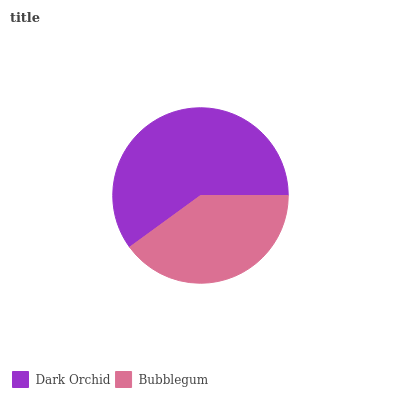Is Bubblegum the minimum?
Answer yes or no. Yes. Is Dark Orchid the maximum?
Answer yes or no. Yes. Is Bubblegum the maximum?
Answer yes or no. No. Is Dark Orchid greater than Bubblegum?
Answer yes or no. Yes. Is Bubblegum less than Dark Orchid?
Answer yes or no. Yes. Is Bubblegum greater than Dark Orchid?
Answer yes or no. No. Is Dark Orchid less than Bubblegum?
Answer yes or no. No. Is Dark Orchid the high median?
Answer yes or no. Yes. Is Bubblegum the low median?
Answer yes or no. Yes. Is Bubblegum the high median?
Answer yes or no. No. Is Dark Orchid the low median?
Answer yes or no. No. 